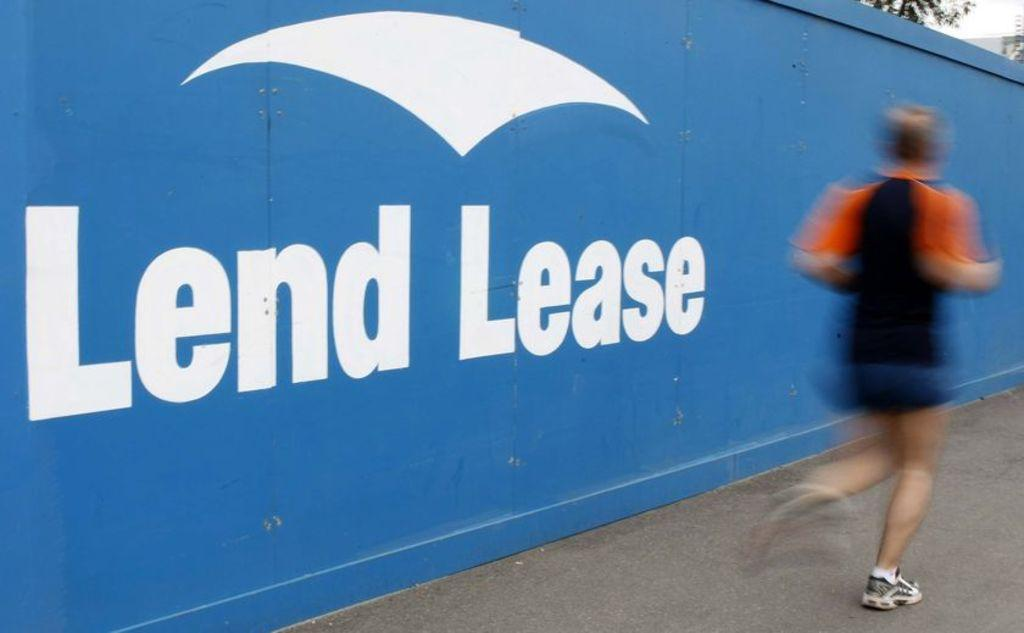What is the person in the image doing? The person is running in the image. What can be seen behind the person? There is a blue wall in the image. Is there any text or symbols on the blue wall? Yes, there is writing on the blue wall. What type of collar is the committee wearing in the image? There is no committee or collar present in the image. What shape is the person running in the image? The person running in the image is not a shape; they are a person. 